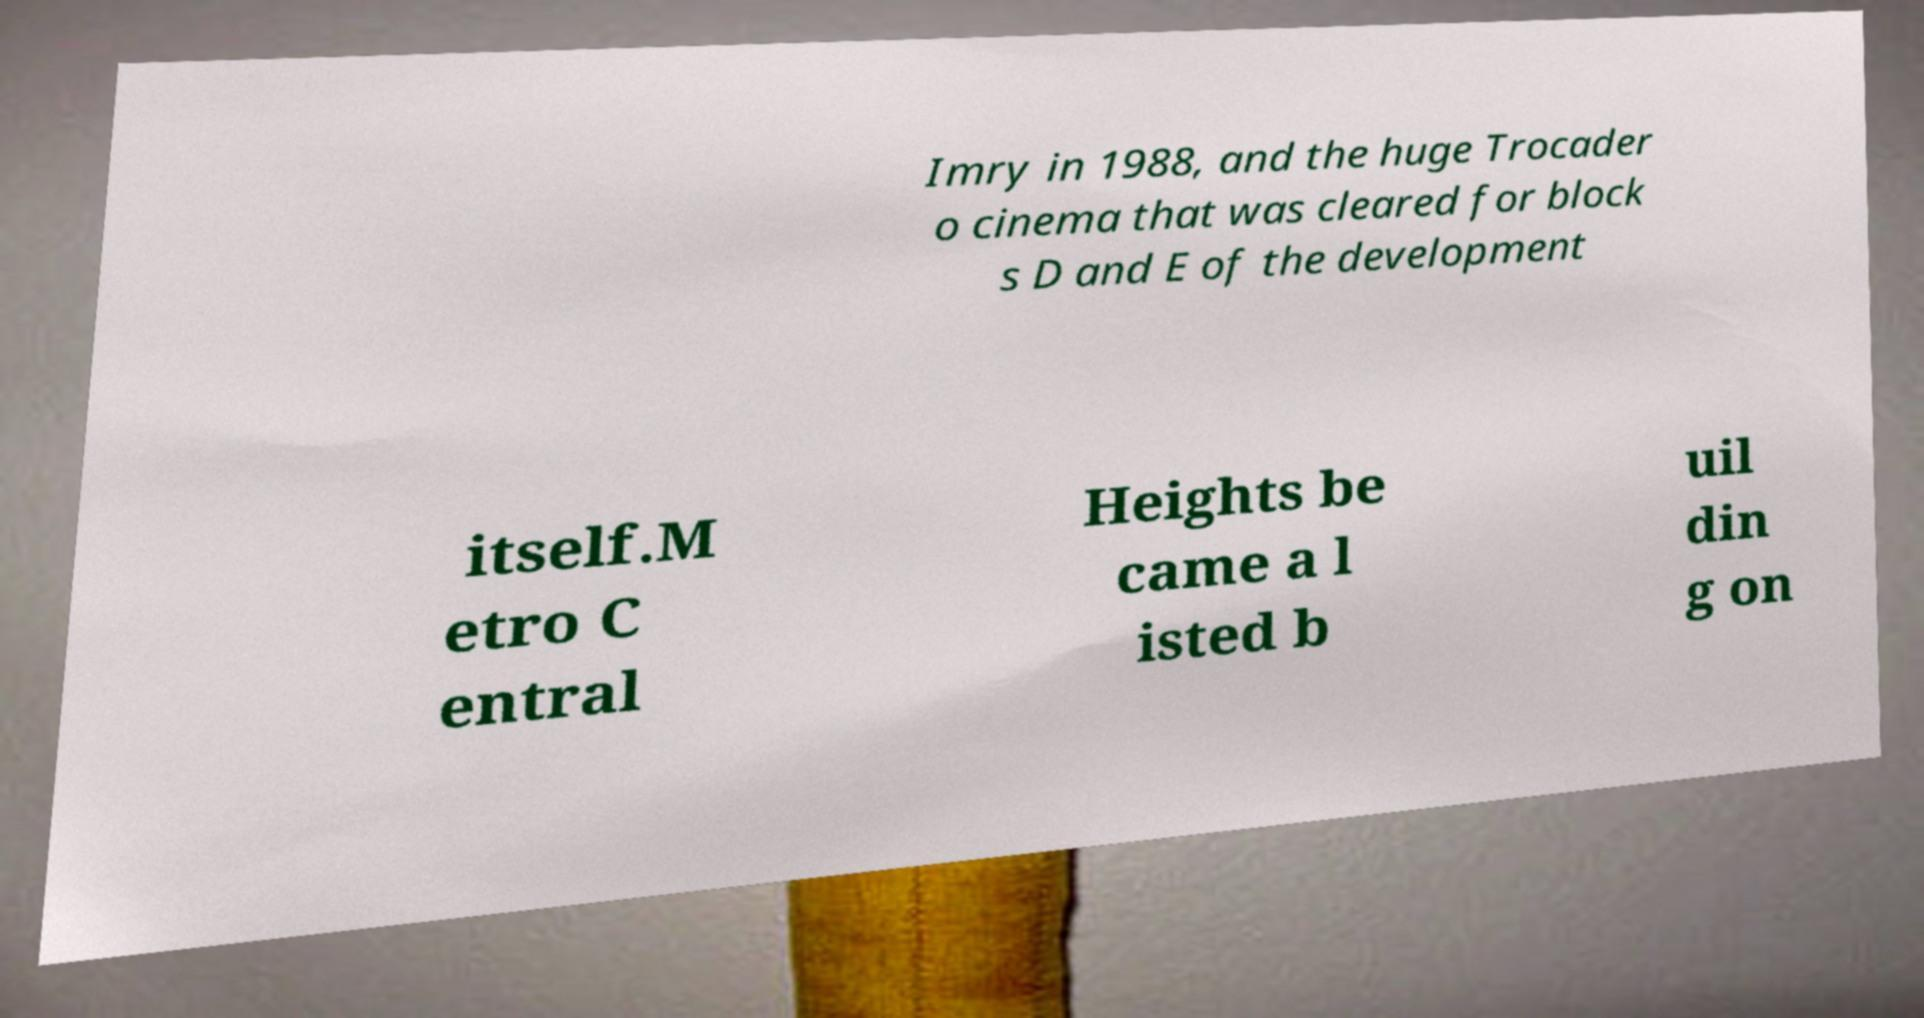Please read and relay the text visible in this image. What does it say? Imry in 1988, and the huge Trocader o cinema that was cleared for block s D and E of the development itself.M etro C entral Heights be came a l isted b uil din g on 